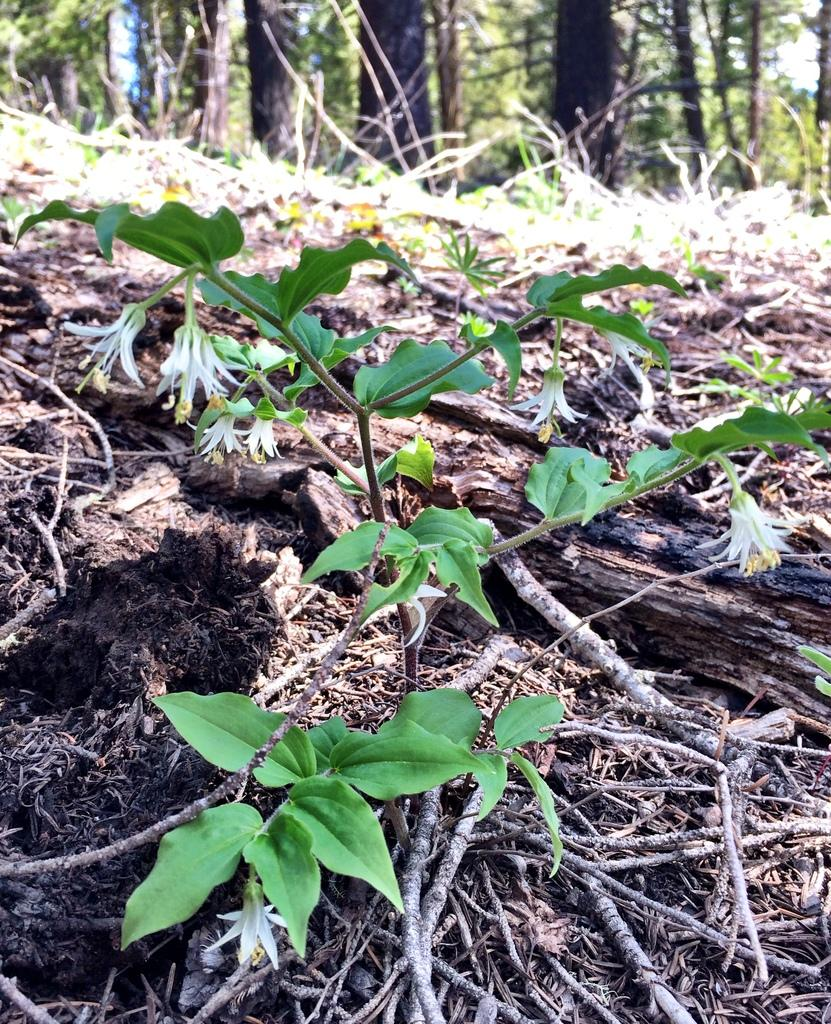What type of plant can be seen in the image? There is a plant with flowers in the image. What else is present on the ground in the image? There are dried branches on the ground in the image. What part of the trees is visible in the image? The bark of trees is visible in the image. How many trees are in the group visible in the image? There is a group of trees in the image. What is visible in the background of the image? The sky is visible in the image. What type of lace can be seen on the trees in the image? There is no lace present on the trees in the image; it is a natural scene with trees, flowers, and branches. 